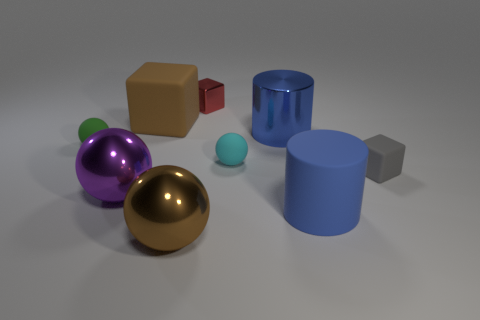What number of things are large brown objects that are right of the large brown rubber thing or large brown things that are to the right of the brown rubber object?
Keep it short and to the point. 1. There is a block on the right side of the red cube; does it have the same size as the brown object behind the small gray matte thing?
Ensure brevity in your answer.  No. There is a large matte object on the left side of the blue metallic object; is there a tiny rubber thing right of it?
Offer a terse response. Yes. What number of green matte things are left of the gray object?
Keep it short and to the point. 1. What number of other objects are the same color as the tiny metal cube?
Keep it short and to the point. 0. Are there fewer tiny green rubber things that are in front of the big brown shiny ball than large purple spheres that are to the left of the large brown matte block?
Offer a terse response. Yes. What number of objects are tiny green rubber things that are to the left of the red metal object or tiny shiny cubes?
Offer a very short reply. 2. There is a brown matte cube; is it the same size as the brown thing in front of the blue rubber thing?
Offer a terse response. Yes. What is the size of the red metal thing that is the same shape as the small gray rubber object?
Your answer should be compact. Small. What number of big blue objects are in front of the blue metallic cylinder to the left of the tiny rubber thing in front of the cyan rubber thing?
Your answer should be compact. 1. 